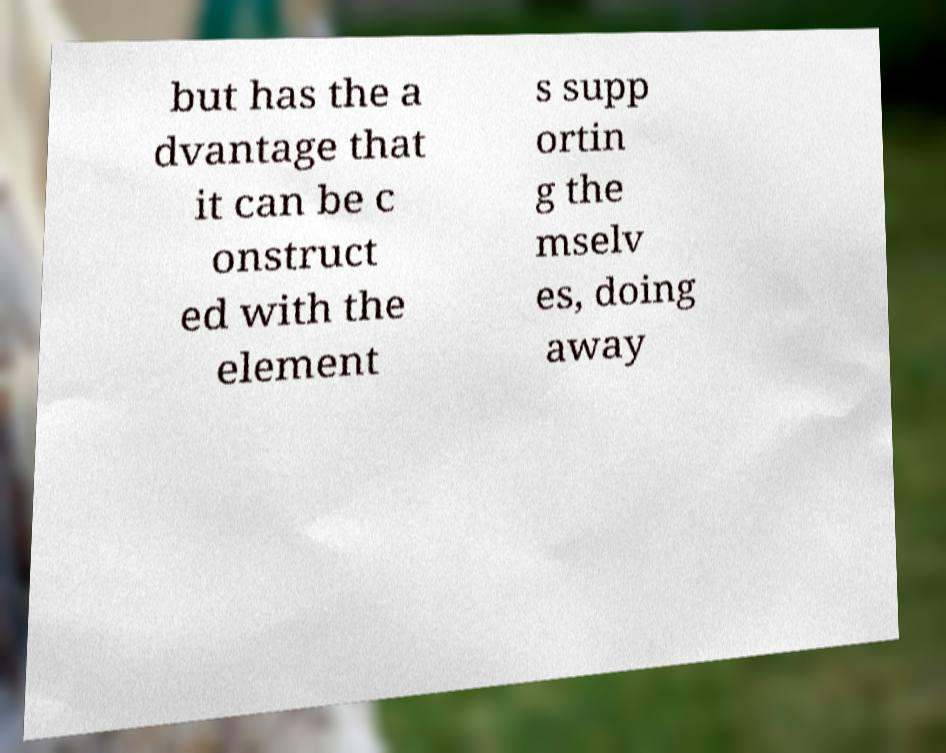Please read and relay the text visible in this image. What does it say? but has the a dvantage that it can be c onstruct ed with the element s supp ortin g the mselv es, doing away 